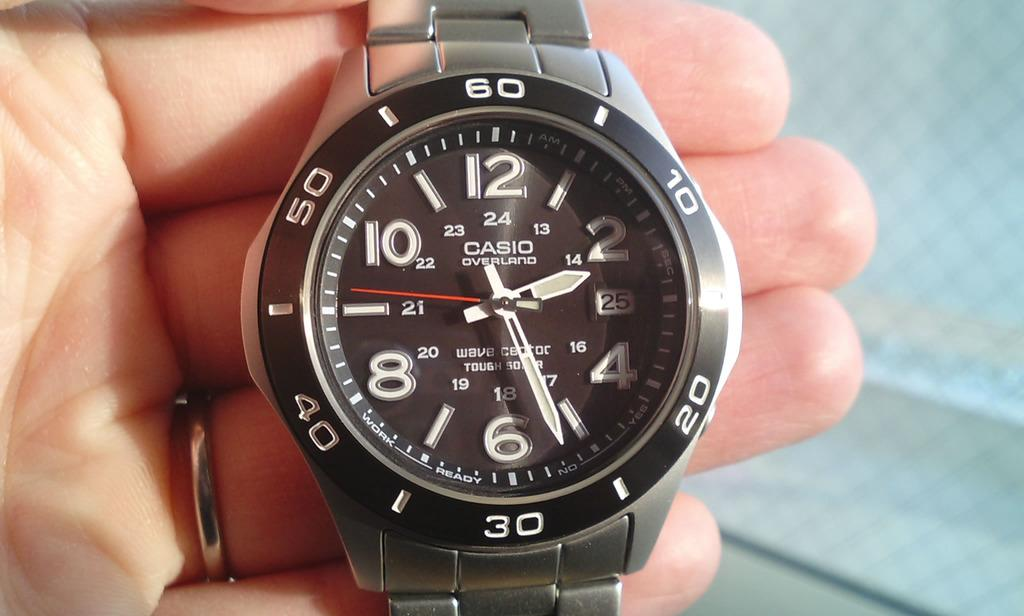<image>
Offer a succinct explanation of the picture presented. Person holding a watch which says CASIO on the face. 